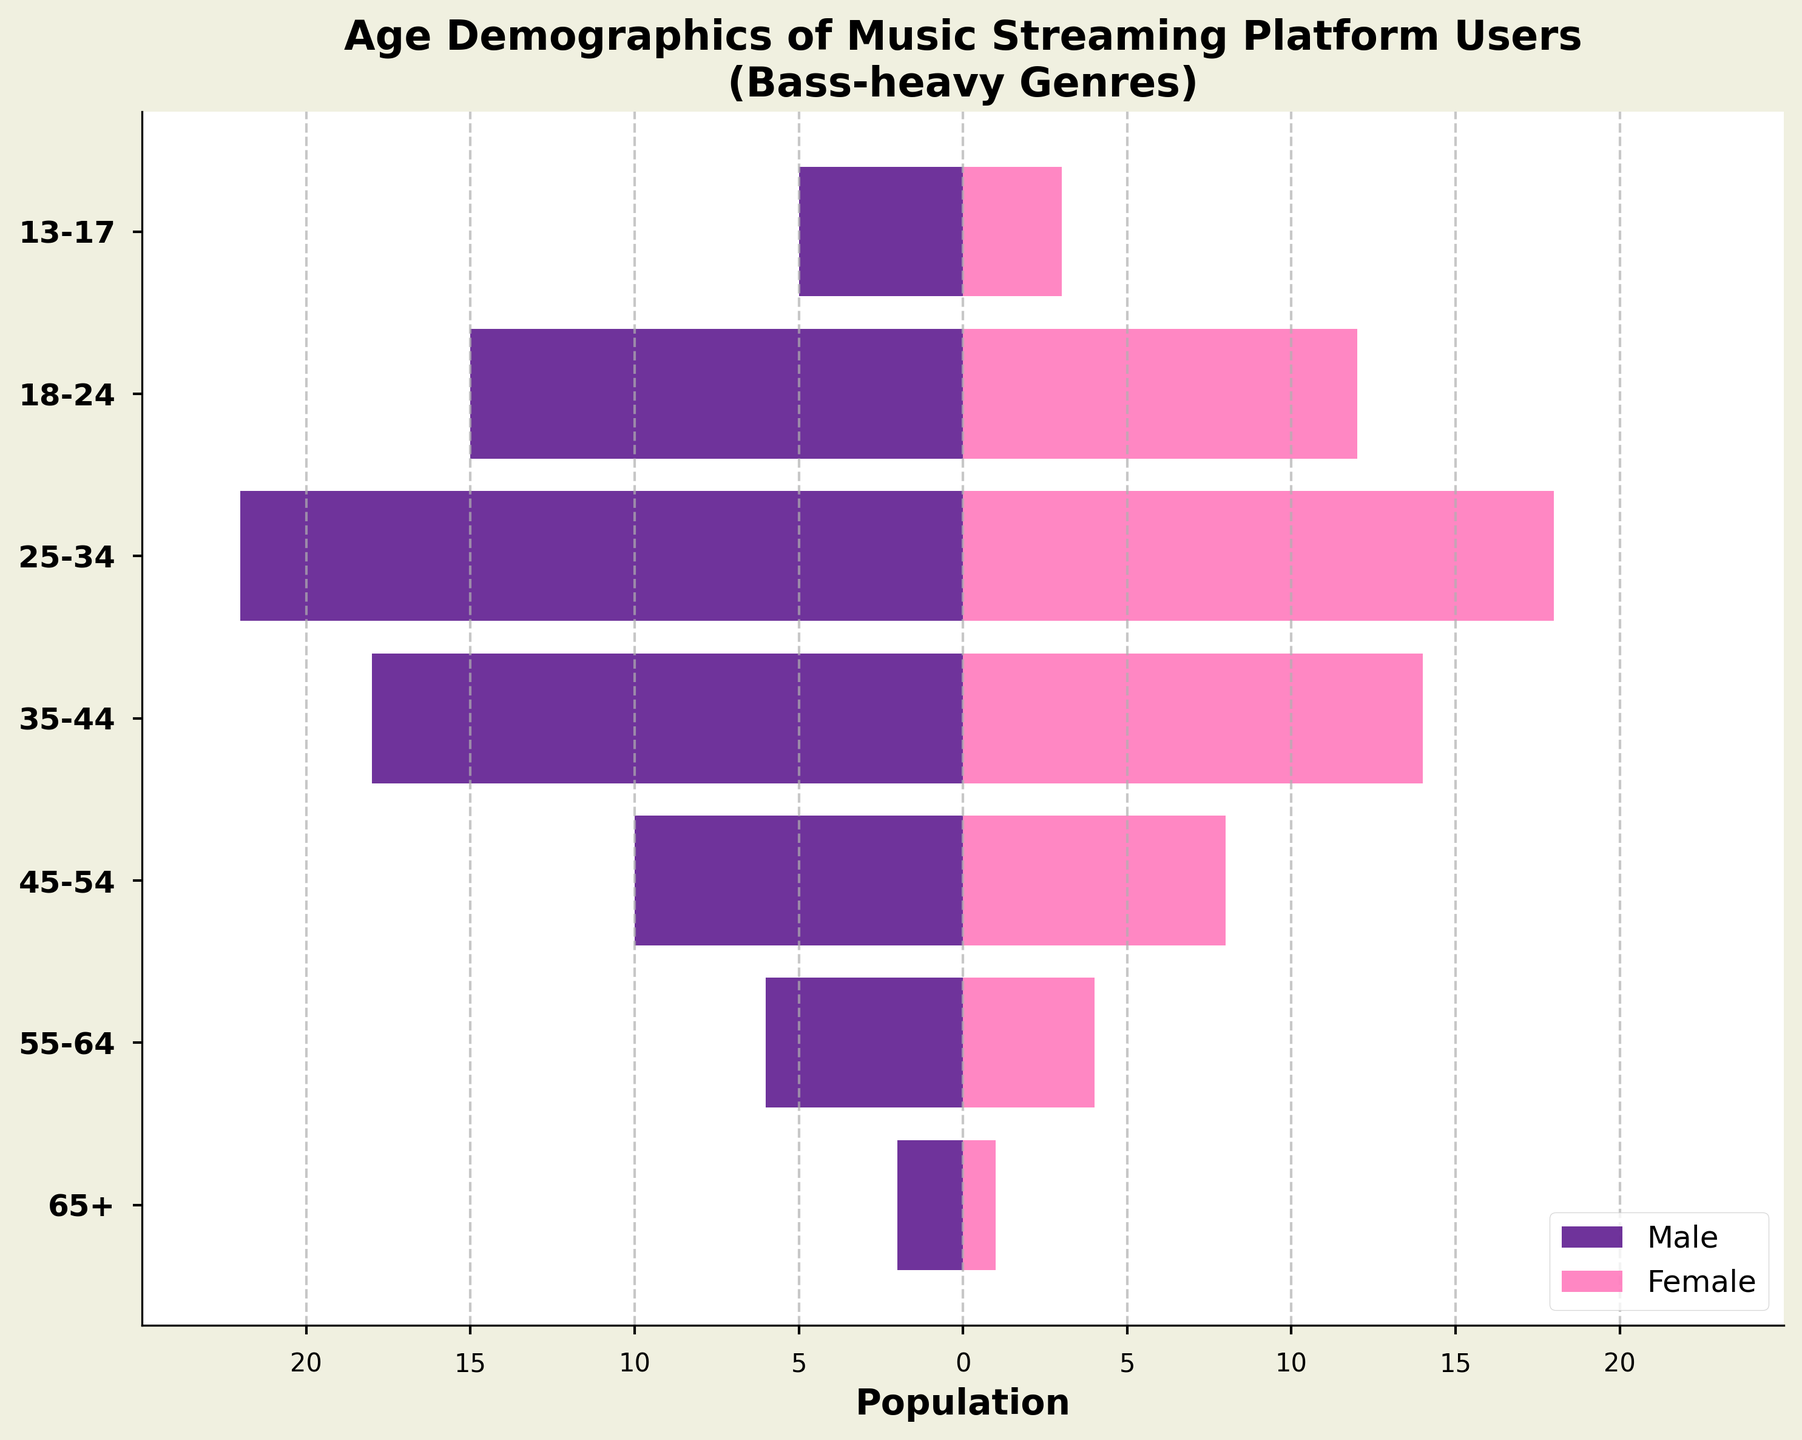What is the title of the figure? Look at the top of the figure where the title is prominently displayed.
Answer: Age Demographics of Music Streaming Platform Users (Bass-heavy Genres) What are the colors used to represent males and females? Check the legend or the color of the bars representing each gender.
Answer: Males: Indigo, Females: Pink Which age group has the largest male population? Look at the lengths of the indigo bars representing males in each age group. The longest bar indicates the largest population.
Answer: 25-34 What is the total number of users aged 35-44? Sum the number of males and females in the 35-44 age group. Males: 18, Females: 14. So, 18 + 14 = 32.
Answer: 32 Is the number of males greater than the number of females in the 18-24 age range? Compare the length of the indigo bar (males) with the pink bar (females) in the 18-24 age group. Males: 15, Females: 12.
Answer: Yes How does the female population change from the 13-17 age group to the 25-34 age group? Subtract the female users in the 13-17 age group from those in the 25-34 age group. 25-34: 18, 13-17: 3, change = 18 - 3 = 15.
Answer: Increases by 15 Which age group has the smallest number of users overall? Add the male and female users for each age group and identify the smallest total. 65+: Males 2, Females 1, Total 3.
Answer: 65+ How many more males than females are there in the 45-54 age group? Subtract the number of females from the number of males in the 45-54 age group. Males: 10, Females: 8. Difference = 10 - 8 = 2.
Answer: 2 Which age group shows the smallest difference between the number of males and females? Calculate the absolute difference between the number of males and females for each age group and identify the smallest difference. Age 35-44: 18 - 14 = 4.
Answer: 35-44 